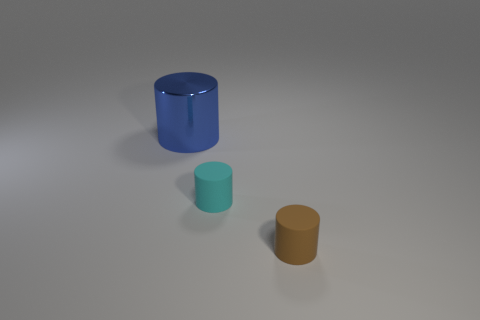Add 2 big cylinders. How many objects exist? 5 Subtract 0 red spheres. How many objects are left? 3 Subtract all brown things. Subtract all cyan matte cylinders. How many objects are left? 1 Add 3 brown rubber cylinders. How many brown rubber cylinders are left? 4 Add 2 tiny purple metal things. How many tiny purple metal things exist? 2 